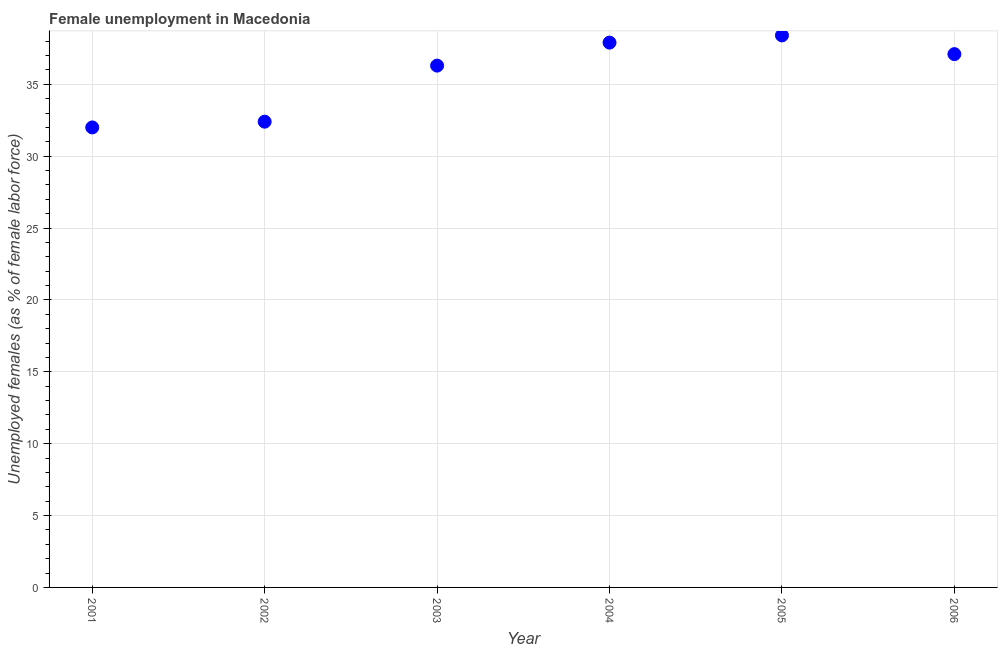Across all years, what is the maximum unemployed females population?
Keep it short and to the point. 38.4. In which year was the unemployed females population minimum?
Provide a short and direct response. 2001. What is the sum of the unemployed females population?
Make the answer very short. 214.1. What is the difference between the unemployed females population in 2004 and 2005?
Your answer should be compact. -0.5. What is the average unemployed females population per year?
Offer a terse response. 35.68. What is the median unemployed females population?
Your answer should be very brief. 36.7. Do a majority of the years between 2005 and 2004 (inclusive) have unemployed females population greater than 15 %?
Your answer should be compact. No. What is the ratio of the unemployed females population in 2002 to that in 2003?
Give a very brief answer. 0.89. What is the difference between the highest and the second highest unemployed females population?
Offer a very short reply. 0.5. Is the sum of the unemployed females population in 2001 and 2002 greater than the maximum unemployed females population across all years?
Your answer should be compact. Yes. What is the difference between the highest and the lowest unemployed females population?
Your response must be concise. 6.4. Does the unemployed females population monotonically increase over the years?
Your response must be concise. No. How many years are there in the graph?
Keep it short and to the point. 6. What is the difference between two consecutive major ticks on the Y-axis?
Provide a succinct answer. 5. Are the values on the major ticks of Y-axis written in scientific E-notation?
Your answer should be compact. No. Does the graph contain any zero values?
Offer a very short reply. No. Does the graph contain grids?
Provide a short and direct response. Yes. What is the title of the graph?
Your answer should be compact. Female unemployment in Macedonia. What is the label or title of the Y-axis?
Provide a short and direct response. Unemployed females (as % of female labor force). What is the Unemployed females (as % of female labor force) in 2001?
Make the answer very short. 32. What is the Unemployed females (as % of female labor force) in 2002?
Give a very brief answer. 32.4. What is the Unemployed females (as % of female labor force) in 2003?
Provide a succinct answer. 36.3. What is the Unemployed females (as % of female labor force) in 2004?
Ensure brevity in your answer.  37.9. What is the Unemployed females (as % of female labor force) in 2005?
Your answer should be compact. 38.4. What is the Unemployed females (as % of female labor force) in 2006?
Offer a terse response. 37.1. What is the difference between the Unemployed females (as % of female labor force) in 2001 and 2003?
Your response must be concise. -4.3. What is the difference between the Unemployed females (as % of female labor force) in 2001 and 2004?
Keep it short and to the point. -5.9. What is the difference between the Unemployed females (as % of female labor force) in 2002 and 2004?
Keep it short and to the point. -5.5. What is the difference between the Unemployed females (as % of female labor force) in 2003 and 2004?
Your answer should be compact. -1.6. What is the difference between the Unemployed females (as % of female labor force) in 2003 and 2006?
Your answer should be very brief. -0.8. What is the difference between the Unemployed females (as % of female labor force) in 2004 and 2006?
Give a very brief answer. 0.8. What is the ratio of the Unemployed females (as % of female labor force) in 2001 to that in 2002?
Offer a very short reply. 0.99. What is the ratio of the Unemployed females (as % of female labor force) in 2001 to that in 2003?
Make the answer very short. 0.88. What is the ratio of the Unemployed females (as % of female labor force) in 2001 to that in 2004?
Make the answer very short. 0.84. What is the ratio of the Unemployed females (as % of female labor force) in 2001 to that in 2005?
Your answer should be very brief. 0.83. What is the ratio of the Unemployed females (as % of female labor force) in 2001 to that in 2006?
Ensure brevity in your answer.  0.86. What is the ratio of the Unemployed females (as % of female labor force) in 2002 to that in 2003?
Provide a succinct answer. 0.89. What is the ratio of the Unemployed females (as % of female labor force) in 2002 to that in 2004?
Your answer should be compact. 0.85. What is the ratio of the Unemployed females (as % of female labor force) in 2002 to that in 2005?
Ensure brevity in your answer.  0.84. What is the ratio of the Unemployed females (as % of female labor force) in 2002 to that in 2006?
Give a very brief answer. 0.87. What is the ratio of the Unemployed females (as % of female labor force) in 2003 to that in 2004?
Your response must be concise. 0.96. What is the ratio of the Unemployed females (as % of female labor force) in 2003 to that in 2005?
Offer a very short reply. 0.94. What is the ratio of the Unemployed females (as % of female labor force) in 2003 to that in 2006?
Provide a succinct answer. 0.98. What is the ratio of the Unemployed females (as % of female labor force) in 2004 to that in 2005?
Your answer should be very brief. 0.99. What is the ratio of the Unemployed females (as % of female labor force) in 2005 to that in 2006?
Give a very brief answer. 1.03. 